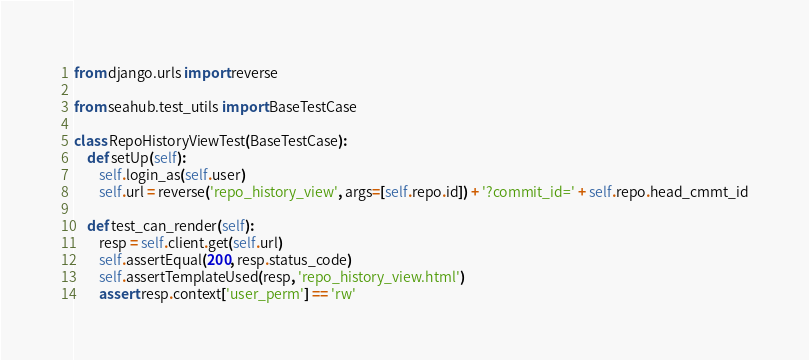Convert code to text. <code><loc_0><loc_0><loc_500><loc_500><_Python_>from django.urls import reverse

from seahub.test_utils import BaseTestCase

class RepoHistoryViewTest(BaseTestCase):
    def setUp(self):
        self.login_as(self.user)
        self.url = reverse('repo_history_view', args=[self.repo.id]) + '?commit_id=' + self.repo.head_cmmt_id

    def test_can_render(self):
        resp = self.client.get(self.url)
        self.assertEqual(200, resp.status_code)
        self.assertTemplateUsed(resp, 'repo_history_view.html')
        assert resp.context['user_perm'] == 'rw'
</code> 